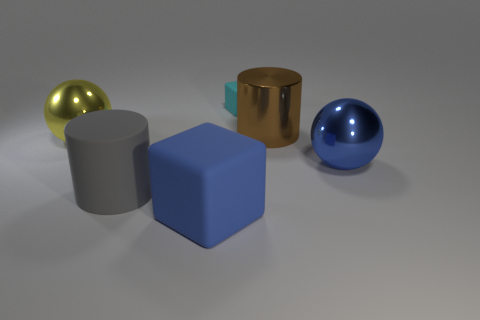Are there any other things that have the same size as the cyan rubber cube?
Keep it short and to the point. No. There is a large blue thing that is the same shape as the small object; what is it made of?
Your answer should be very brief. Rubber. Is the color of the big block the same as the ball that is on the right side of the small rubber block?
Offer a very short reply. Yes. There is a shiny ball right of the big metal cylinder; is its color the same as the large block?
Your answer should be compact. Yes. Does the brown cylinder have the same material as the big gray thing?
Offer a very short reply. No. What number of blue shiny things are the same shape as the big brown object?
Provide a short and direct response. 0. What is the size of the cyan object that is made of the same material as the gray cylinder?
Make the answer very short. Small. What is the color of the metallic object that is both in front of the brown shiny cylinder and right of the big yellow shiny ball?
Make the answer very short. Blue. What number of blue things have the same size as the blue metal sphere?
Your answer should be very brief. 1. There is a thing that is the same color as the big block; what is its size?
Offer a very short reply. Large. 